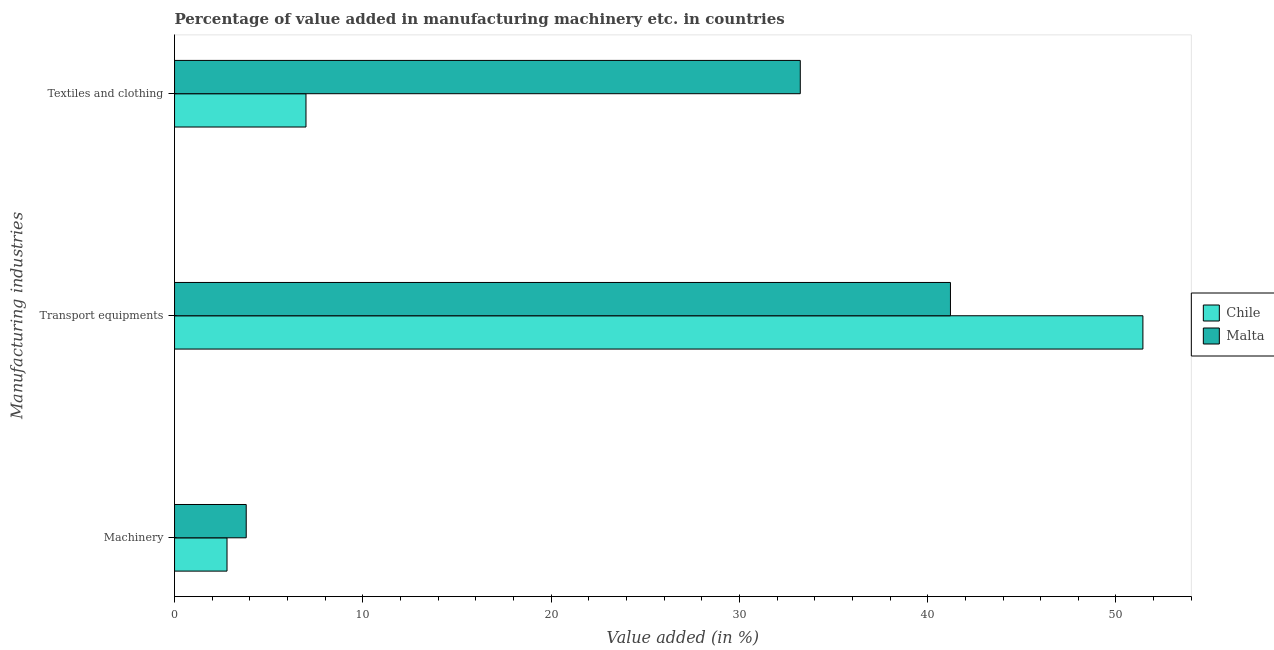How many different coloured bars are there?
Keep it short and to the point. 2. Are the number of bars per tick equal to the number of legend labels?
Offer a terse response. Yes. Are the number of bars on each tick of the Y-axis equal?
Ensure brevity in your answer.  Yes. What is the label of the 3rd group of bars from the top?
Offer a very short reply. Machinery. What is the value added in manufacturing machinery in Malta?
Your answer should be very brief. 3.81. Across all countries, what is the maximum value added in manufacturing textile and clothing?
Ensure brevity in your answer.  33.23. Across all countries, what is the minimum value added in manufacturing textile and clothing?
Your answer should be very brief. 6.98. In which country was the value added in manufacturing machinery maximum?
Offer a very short reply. Malta. In which country was the value added in manufacturing machinery minimum?
Your response must be concise. Chile. What is the total value added in manufacturing machinery in the graph?
Give a very brief answer. 6.59. What is the difference between the value added in manufacturing machinery in Chile and that in Malta?
Offer a very short reply. -1.02. What is the difference between the value added in manufacturing machinery in Malta and the value added in manufacturing textile and clothing in Chile?
Offer a terse response. -3.17. What is the average value added in manufacturing textile and clothing per country?
Keep it short and to the point. 20.11. What is the difference between the value added in manufacturing transport equipments and value added in manufacturing textile and clothing in Malta?
Make the answer very short. 7.98. In how many countries, is the value added in manufacturing transport equipments greater than 8 %?
Provide a short and direct response. 2. What is the ratio of the value added in manufacturing textile and clothing in Chile to that in Malta?
Provide a short and direct response. 0.21. Is the value added in manufacturing machinery in Chile less than that in Malta?
Ensure brevity in your answer.  Yes. Is the difference between the value added in manufacturing transport equipments in Chile and Malta greater than the difference between the value added in manufacturing machinery in Chile and Malta?
Keep it short and to the point. Yes. What is the difference between the highest and the second highest value added in manufacturing textile and clothing?
Ensure brevity in your answer.  26.25. What is the difference between the highest and the lowest value added in manufacturing machinery?
Your answer should be very brief. 1.02. In how many countries, is the value added in manufacturing machinery greater than the average value added in manufacturing machinery taken over all countries?
Give a very brief answer. 1. Is the sum of the value added in manufacturing textile and clothing in Malta and Chile greater than the maximum value added in manufacturing machinery across all countries?
Offer a very short reply. Yes. What does the 1st bar from the top in Transport equipments represents?
Offer a very short reply. Malta. What does the 2nd bar from the bottom in Textiles and clothing represents?
Your answer should be compact. Malta. Is it the case that in every country, the sum of the value added in manufacturing machinery and value added in manufacturing transport equipments is greater than the value added in manufacturing textile and clothing?
Make the answer very short. Yes. How many bars are there?
Provide a succinct answer. 6. Are all the bars in the graph horizontal?
Keep it short and to the point. Yes. Are the values on the major ticks of X-axis written in scientific E-notation?
Offer a terse response. No. Does the graph contain any zero values?
Your answer should be very brief. No. How are the legend labels stacked?
Ensure brevity in your answer.  Vertical. What is the title of the graph?
Make the answer very short. Percentage of value added in manufacturing machinery etc. in countries. Does "India" appear as one of the legend labels in the graph?
Offer a very short reply. No. What is the label or title of the X-axis?
Offer a very short reply. Value added (in %). What is the label or title of the Y-axis?
Offer a very short reply. Manufacturing industries. What is the Value added (in %) of Chile in Machinery?
Provide a succinct answer. 2.79. What is the Value added (in %) in Malta in Machinery?
Your answer should be very brief. 3.81. What is the Value added (in %) in Chile in Transport equipments?
Provide a short and direct response. 51.43. What is the Value added (in %) of Malta in Transport equipments?
Your response must be concise. 41.21. What is the Value added (in %) in Chile in Textiles and clothing?
Offer a very short reply. 6.98. What is the Value added (in %) of Malta in Textiles and clothing?
Provide a succinct answer. 33.23. Across all Manufacturing industries, what is the maximum Value added (in %) of Chile?
Make the answer very short. 51.43. Across all Manufacturing industries, what is the maximum Value added (in %) of Malta?
Offer a very short reply. 41.21. Across all Manufacturing industries, what is the minimum Value added (in %) of Chile?
Your response must be concise. 2.79. Across all Manufacturing industries, what is the minimum Value added (in %) in Malta?
Give a very brief answer. 3.81. What is the total Value added (in %) of Chile in the graph?
Your answer should be compact. 61.2. What is the total Value added (in %) of Malta in the graph?
Give a very brief answer. 78.25. What is the difference between the Value added (in %) in Chile in Machinery and that in Transport equipments?
Offer a terse response. -48.64. What is the difference between the Value added (in %) in Malta in Machinery and that in Transport equipments?
Your answer should be compact. -37.4. What is the difference between the Value added (in %) of Chile in Machinery and that in Textiles and clothing?
Ensure brevity in your answer.  -4.19. What is the difference between the Value added (in %) in Malta in Machinery and that in Textiles and clothing?
Offer a terse response. -29.43. What is the difference between the Value added (in %) of Chile in Transport equipments and that in Textiles and clothing?
Keep it short and to the point. 44.45. What is the difference between the Value added (in %) of Malta in Transport equipments and that in Textiles and clothing?
Provide a short and direct response. 7.98. What is the difference between the Value added (in %) in Chile in Machinery and the Value added (in %) in Malta in Transport equipments?
Ensure brevity in your answer.  -38.42. What is the difference between the Value added (in %) in Chile in Machinery and the Value added (in %) in Malta in Textiles and clothing?
Offer a very short reply. -30.45. What is the difference between the Value added (in %) of Chile in Transport equipments and the Value added (in %) of Malta in Textiles and clothing?
Provide a succinct answer. 18.2. What is the average Value added (in %) of Chile per Manufacturing industries?
Keep it short and to the point. 20.4. What is the average Value added (in %) of Malta per Manufacturing industries?
Give a very brief answer. 26.08. What is the difference between the Value added (in %) of Chile and Value added (in %) of Malta in Machinery?
Make the answer very short. -1.02. What is the difference between the Value added (in %) in Chile and Value added (in %) in Malta in Transport equipments?
Provide a short and direct response. 10.22. What is the difference between the Value added (in %) in Chile and Value added (in %) in Malta in Textiles and clothing?
Keep it short and to the point. -26.25. What is the ratio of the Value added (in %) of Chile in Machinery to that in Transport equipments?
Offer a terse response. 0.05. What is the ratio of the Value added (in %) in Malta in Machinery to that in Transport equipments?
Your answer should be compact. 0.09. What is the ratio of the Value added (in %) in Chile in Machinery to that in Textiles and clothing?
Your answer should be very brief. 0.4. What is the ratio of the Value added (in %) in Malta in Machinery to that in Textiles and clothing?
Ensure brevity in your answer.  0.11. What is the ratio of the Value added (in %) in Chile in Transport equipments to that in Textiles and clothing?
Your response must be concise. 7.37. What is the ratio of the Value added (in %) of Malta in Transport equipments to that in Textiles and clothing?
Provide a succinct answer. 1.24. What is the difference between the highest and the second highest Value added (in %) of Chile?
Make the answer very short. 44.45. What is the difference between the highest and the second highest Value added (in %) of Malta?
Make the answer very short. 7.98. What is the difference between the highest and the lowest Value added (in %) in Chile?
Give a very brief answer. 48.64. What is the difference between the highest and the lowest Value added (in %) of Malta?
Your answer should be compact. 37.4. 